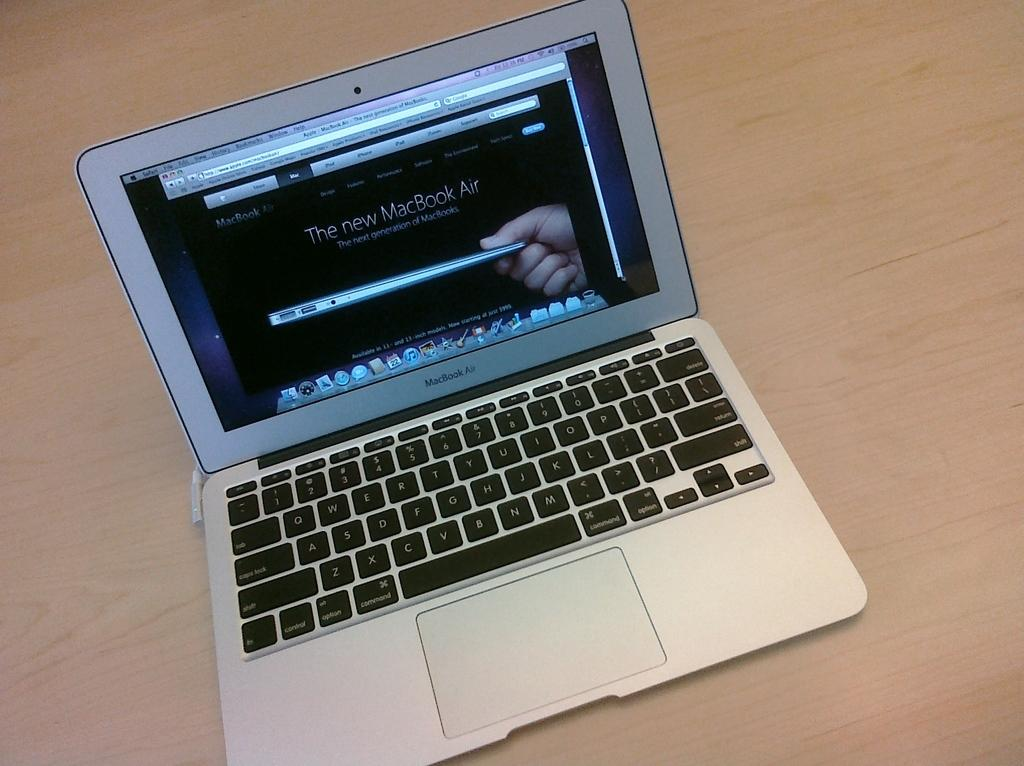What electronic device is visible in the image? There is a laptop in the image. What is the laptop placed on? The laptop is on a wooden surface. Where is the tank located in the image? There is no tank present in the image. What type of stitch is being used to sew the laptop in the image? The laptop is not being sewn, and there is no stitching present in the image. 